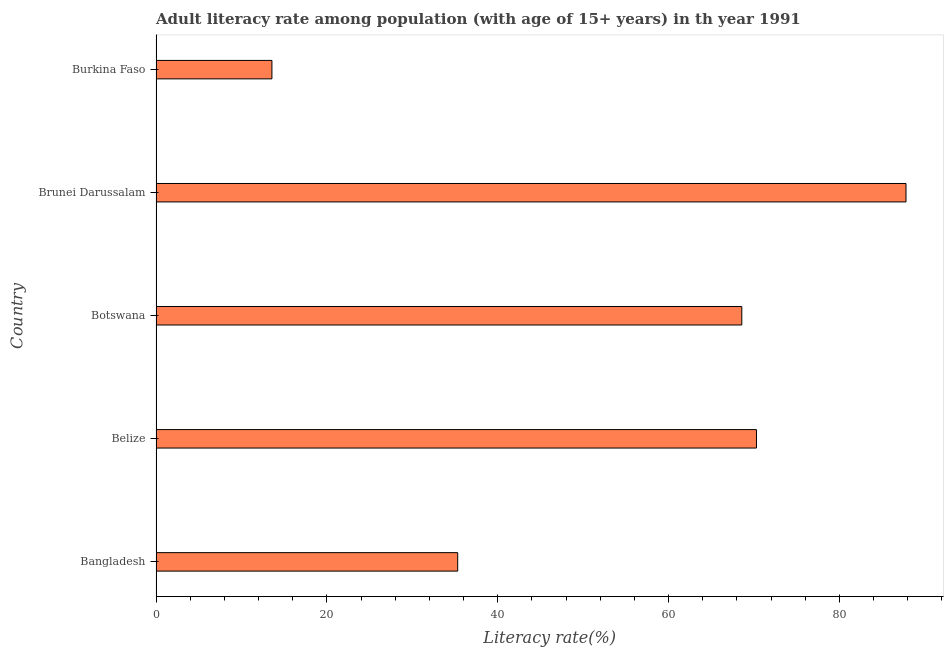Does the graph contain any zero values?
Your answer should be compact. No. What is the title of the graph?
Provide a succinct answer. Adult literacy rate among population (with age of 15+ years) in th year 1991. What is the label or title of the X-axis?
Provide a succinct answer. Literacy rate(%). What is the adult literacy rate in Brunei Darussalam?
Keep it short and to the point. 87.8. Across all countries, what is the maximum adult literacy rate?
Provide a succinct answer. 87.8. Across all countries, what is the minimum adult literacy rate?
Provide a succinct answer. 13.57. In which country was the adult literacy rate maximum?
Your answer should be very brief. Brunei Darussalam. In which country was the adult literacy rate minimum?
Keep it short and to the point. Burkina Faso. What is the sum of the adult literacy rate?
Your answer should be very brief. 275.57. What is the difference between the adult literacy rate in Brunei Darussalam and Burkina Faso?
Your answer should be compact. 74.23. What is the average adult literacy rate per country?
Provide a short and direct response. 55.11. What is the median adult literacy rate?
Give a very brief answer. 68.58. What is the ratio of the adult literacy rate in Belize to that in Burkina Faso?
Provide a succinct answer. 5.18. Is the difference between the adult literacy rate in Belize and Burkina Faso greater than the difference between any two countries?
Keep it short and to the point. No. What is the difference between the highest and the second highest adult literacy rate?
Give a very brief answer. 17.51. Is the sum of the adult literacy rate in Belize and Brunei Darussalam greater than the maximum adult literacy rate across all countries?
Offer a very short reply. Yes. What is the difference between the highest and the lowest adult literacy rate?
Give a very brief answer. 74.23. How many bars are there?
Your answer should be compact. 5. Are all the bars in the graph horizontal?
Give a very brief answer. Yes. What is the difference between two consecutive major ticks on the X-axis?
Offer a very short reply. 20. What is the Literacy rate(%) in Bangladesh?
Your answer should be compact. 35.32. What is the Literacy rate(%) in Belize?
Offer a very short reply. 70.3. What is the Literacy rate(%) in Botswana?
Give a very brief answer. 68.58. What is the Literacy rate(%) of Brunei Darussalam?
Make the answer very short. 87.8. What is the Literacy rate(%) in Burkina Faso?
Your answer should be very brief. 13.57. What is the difference between the Literacy rate(%) in Bangladesh and Belize?
Provide a succinct answer. -34.98. What is the difference between the Literacy rate(%) in Bangladesh and Botswana?
Your response must be concise. -33.26. What is the difference between the Literacy rate(%) in Bangladesh and Brunei Darussalam?
Your response must be concise. -52.48. What is the difference between the Literacy rate(%) in Bangladesh and Burkina Faso?
Your answer should be compact. 21.75. What is the difference between the Literacy rate(%) in Belize and Botswana?
Provide a succinct answer. 1.72. What is the difference between the Literacy rate(%) in Belize and Brunei Darussalam?
Keep it short and to the point. -17.51. What is the difference between the Literacy rate(%) in Belize and Burkina Faso?
Your answer should be very brief. 56.73. What is the difference between the Literacy rate(%) in Botswana and Brunei Darussalam?
Make the answer very short. -19.22. What is the difference between the Literacy rate(%) in Botswana and Burkina Faso?
Make the answer very short. 55.01. What is the difference between the Literacy rate(%) in Brunei Darussalam and Burkina Faso?
Ensure brevity in your answer.  74.23. What is the ratio of the Literacy rate(%) in Bangladesh to that in Belize?
Your answer should be compact. 0.5. What is the ratio of the Literacy rate(%) in Bangladesh to that in Botswana?
Give a very brief answer. 0.52. What is the ratio of the Literacy rate(%) in Bangladesh to that in Brunei Darussalam?
Provide a short and direct response. 0.4. What is the ratio of the Literacy rate(%) in Bangladesh to that in Burkina Faso?
Make the answer very short. 2.6. What is the ratio of the Literacy rate(%) in Belize to that in Brunei Darussalam?
Provide a short and direct response. 0.8. What is the ratio of the Literacy rate(%) in Belize to that in Burkina Faso?
Offer a very short reply. 5.18. What is the ratio of the Literacy rate(%) in Botswana to that in Brunei Darussalam?
Ensure brevity in your answer.  0.78. What is the ratio of the Literacy rate(%) in Botswana to that in Burkina Faso?
Make the answer very short. 5.05. What is the ratio of the Literacy rate(%) in Brunei Darussalam to that in Burkina Faso?
Offer a very short reply. 6.47. 